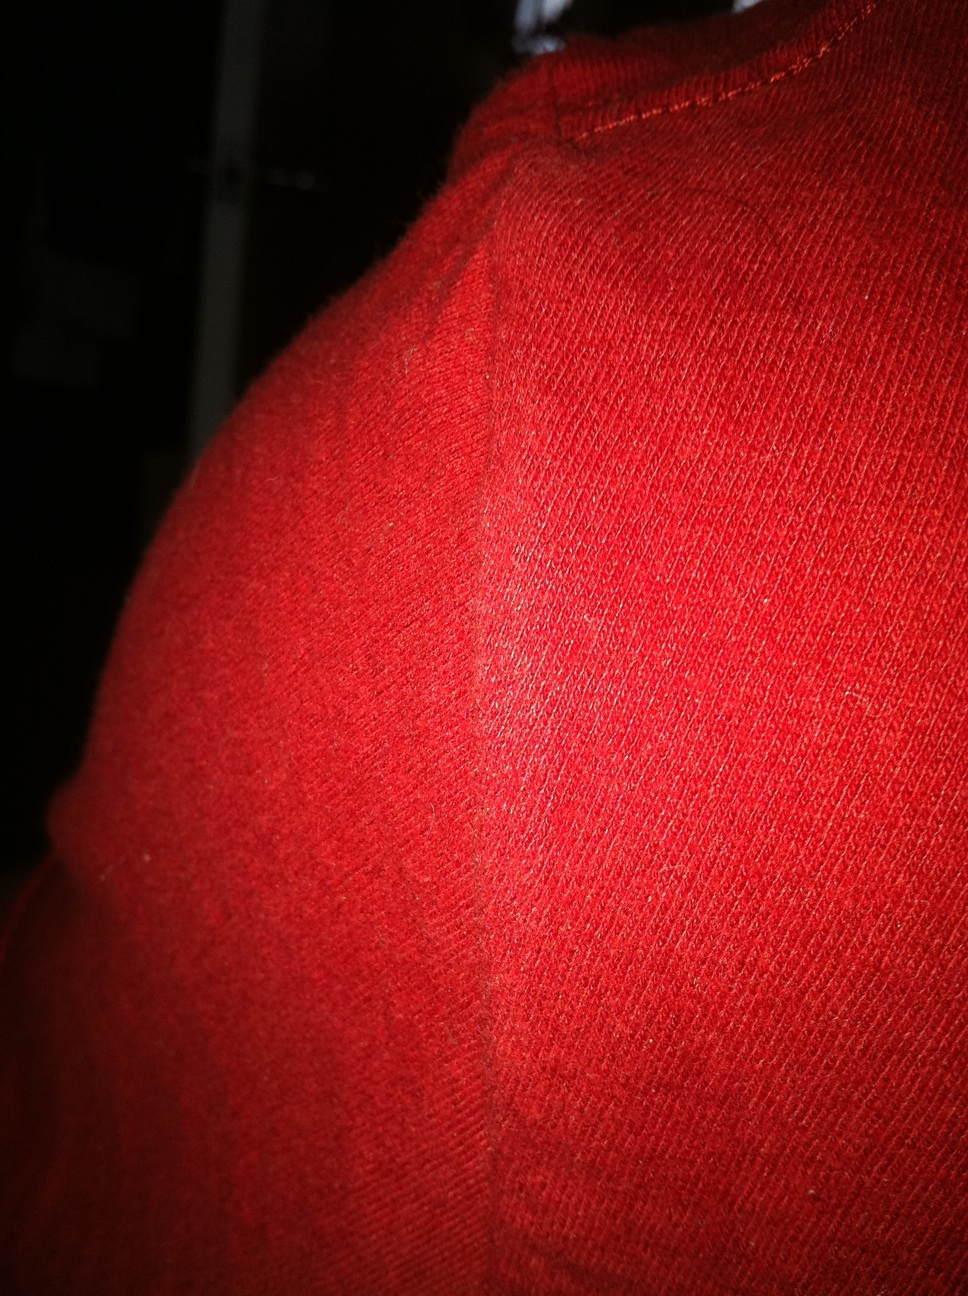What kind of use might this red fabric be suited for? This vibrant red fabric, featuring a ribbed knitted texture, is not only visually striking but also functional. It is ideally suited for creating cozy clothing items such as sweaters, beanies, and scarves. Its texture ensures warmth and comfort, making it perfect for colder seasons. Additionally, its bold color can add a fashionable touch to any winter wardrobe. 